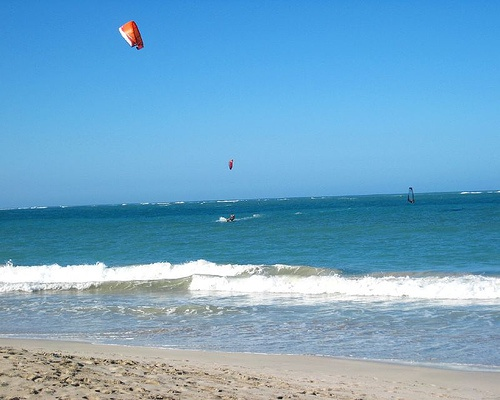Describe the objects in this image and their specific colors. I can see kite in gray, white, brown, maroon, and salmon tones, boat in gray, teal, blue, and navy tones, people in gray, black, blue, and navy tones, and kite in gray and brown tones in this image. 